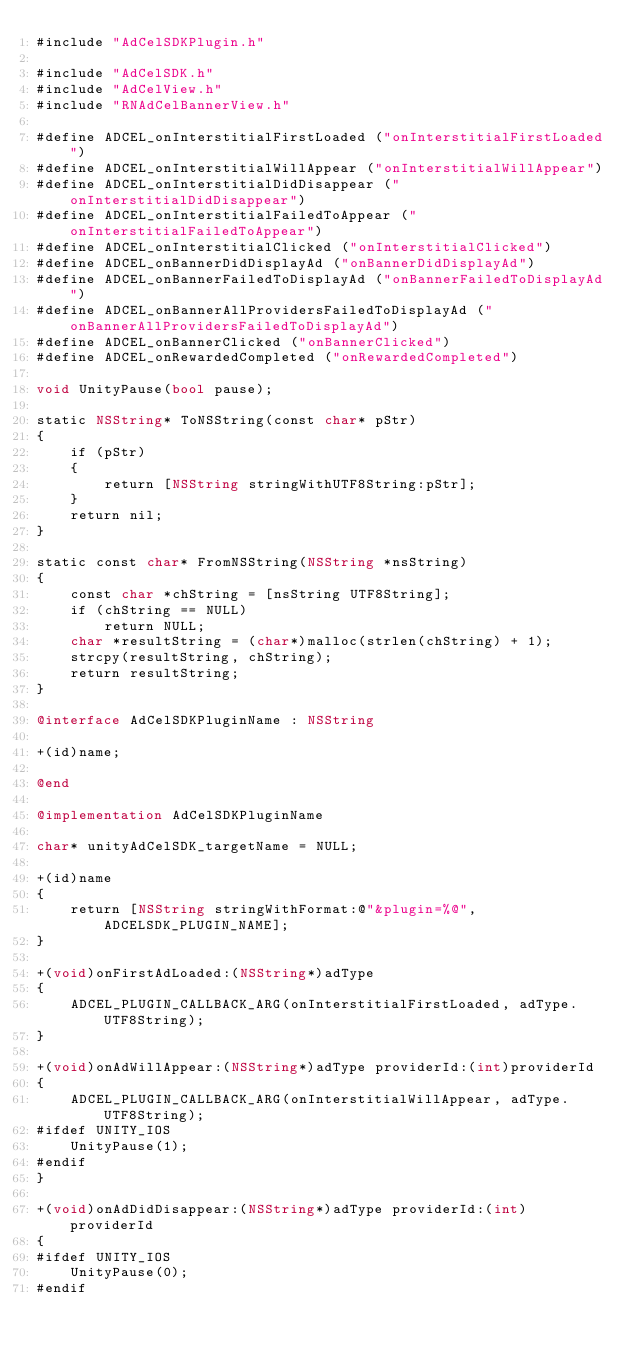Convert code to text. <code><loc_0><loc_0><loc_500><loc_500><_ObjectiveC_>#include "AdCelSDKPlugin.h"

#include "AdCelSDK.h"
#include "AdCelView.h"
#include "RNAdCelBannerView.h"

#define ADCEL_onInterstitialFirstLoaded ("onInterstitialFirstLoaded")
#define ADCEL_onInterstitialWillAppear ("onInterstitialWillAppear")
#define ADCEL_onInterstitialDidDisappear ("onInterstitialDidDisappear")
#define ADCEL_onInterstitialFailedToAppear ("onInterstitialFailedToAppear")
#define ADCEL_onInterstitialClicked ("onInterstitialClicked")
#define ADCEL_onBannerDidDisplayAd ("onBannerDidDisplayAd")
#define ADCEL_onBannerFailedToDisplayAd ("onBannerFailedToDisplayAd")
#define ADCEL_onBannerAllProvidersFailedToDisplayAd ("onBannerAllProvidersFailedToDisplayAd")
#define ADCEL_onBannerClicked ("onBannerClicked")
#define ADCEL_onRewardedCompleted ("onRewardedCompleted")

void UnityPause(bool pause);

static NSString* ToNSString(const char* pStr)
{
    if (pStr)
    {
        return [NSString stringWithUTF8String:pStr];
    }
    return nil;
}

static const char* FromNSString(NSString *nsString)
{
    const char *chString = [nsString UTF8String];
    if (chString == NULL)
        return NULL;
    char *resultString = (char*)malloc(strlen(chString) + 1);
    strcpy(resultString, chString);
    return resultString;
}

@interface AdCelSDKPluginName : NSString

+(id)name;

@end

@implementation AdCelSDKPluginName

char* unityAdCelSDK_targetName = NULL;

+(id)name
{
    return [NSString stringWithFormat:@"&plugin=%@", ADCELSDK_PLUGIN_NAME];
}

+(void)onFirstAdLoaded:(NSString*)adType
{
    ADCEL_PLUGIN_CALLBACK_ARG(onInterstitialFirstLoaded, adType.UTF8String);
}

+(void)onAdWillAppear:(NSString*)adType providerId:(int)providerId
{
    ADCEL_PLUGIN_CALLBACK_ARG(onInterstitialWillAppear, adType.UTF8String);
#ifdef UNITY_IOS
    UnityPause(1);
#endif
}

+(void)onAdDidDisappear:(NSString*)adType providerId:(int)providerId
{
#ifdef UNITY_IOS
    UnityPause(0);
#endif</code> 